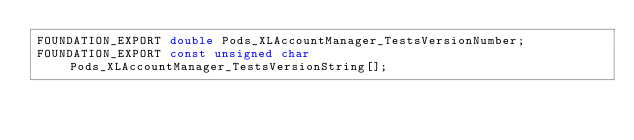<code> <loc_0><loc_0><loc_500><loc_500><_C_>FOUNDATION_EXPORT double Pods_XLAccountManager_TestsVersionNumber;
FOUNDATION_EXPORT const unsigned char Pods_XLAccountManager_TestsVersionString[];

</code> 